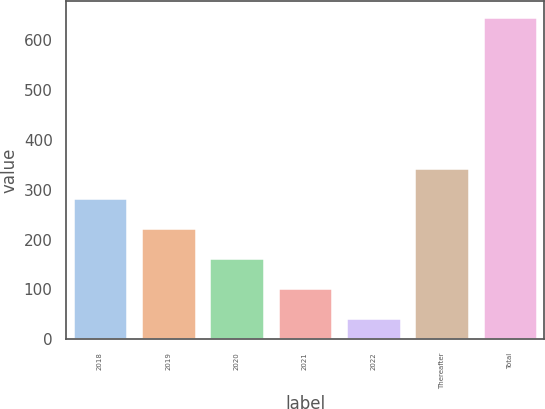Convert chart. <chart><loc_0><loc_0><loc_500><loc_500><bar_chart><fcel>2018<fcel>2019<fcel>2020<fcel>2021<fcel>2022<fcel>Thereafter<fcel>Total<nl><fcel>283.2<fcel>222.9<fcel>162.6<fcel>102.3<fcel>42<fcel>344<fcel>645<nl></chart> 